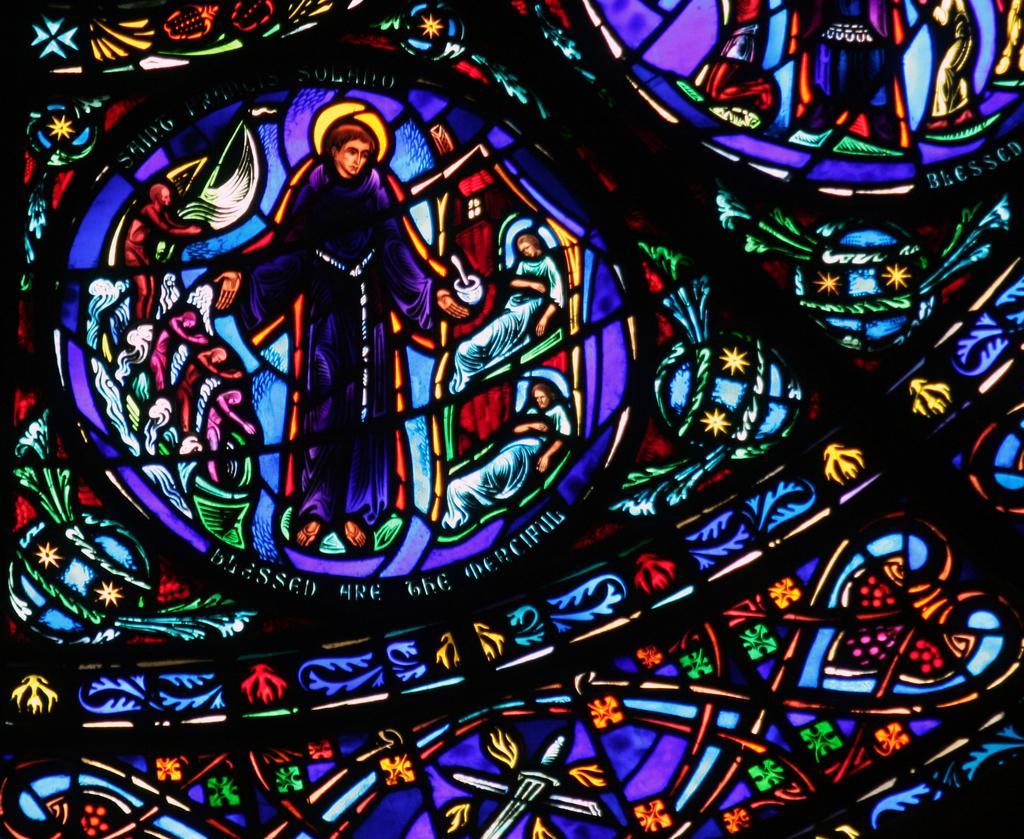Describe this image in one or two sentences. In this image it seems like an art where we can see there is a person in the middle. Below the person there is some text. At the bottom there is some design which is filled with different colors. 